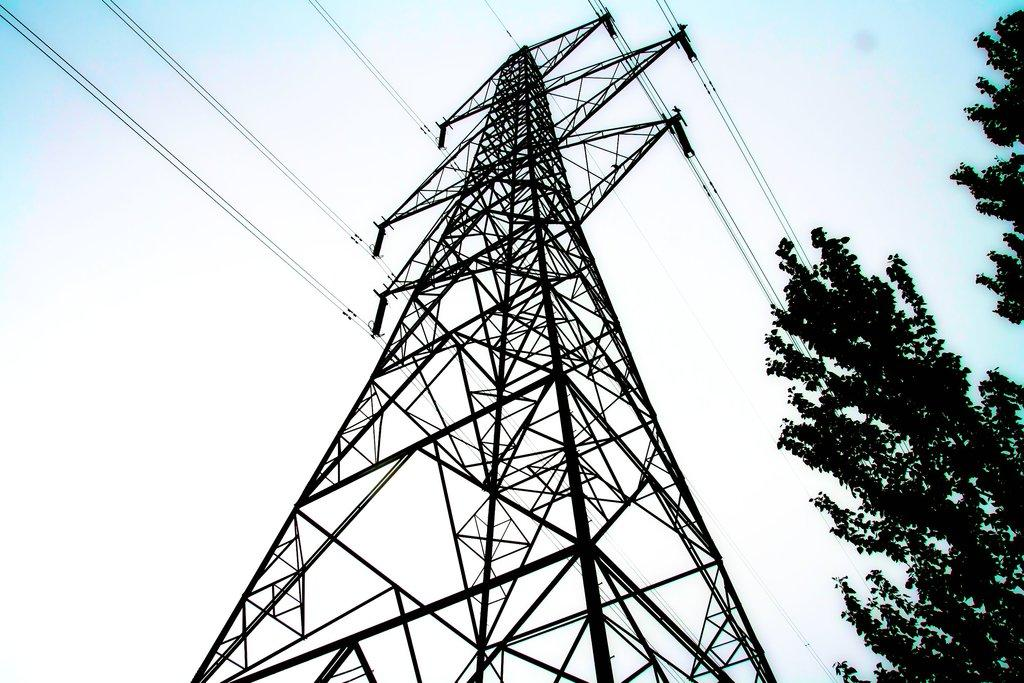What is the main object in the image? There is an electrical pole with a transformer in the image. What can be seen behind the electrical pole? There are trees visible behind the electrical pole. What type of carriage is being pulled by horses in the image? There is no carriage or horses present in the image; it features an electrical pole with a transformer and trees in the background. 